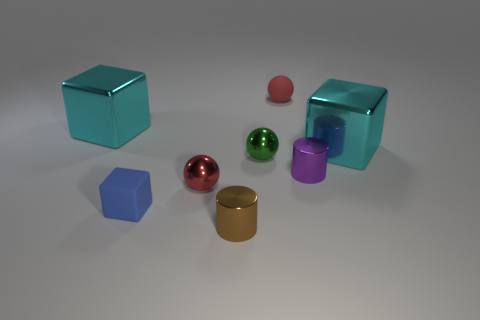Add 1 tiny matte things. How many objects exist? 9 Subtract all cubes. How many objects are left? 5 Add 1 red matte objects. How many red matte objects are left? 2 Add 6 tiny yellow balls. How many tiny yellow balls exist? 6 Subtract 0 gray cylinders. How many objects are left? 8 Subtract all tiny rubber blocks. Subtract all big things. How many objects are left? 5 